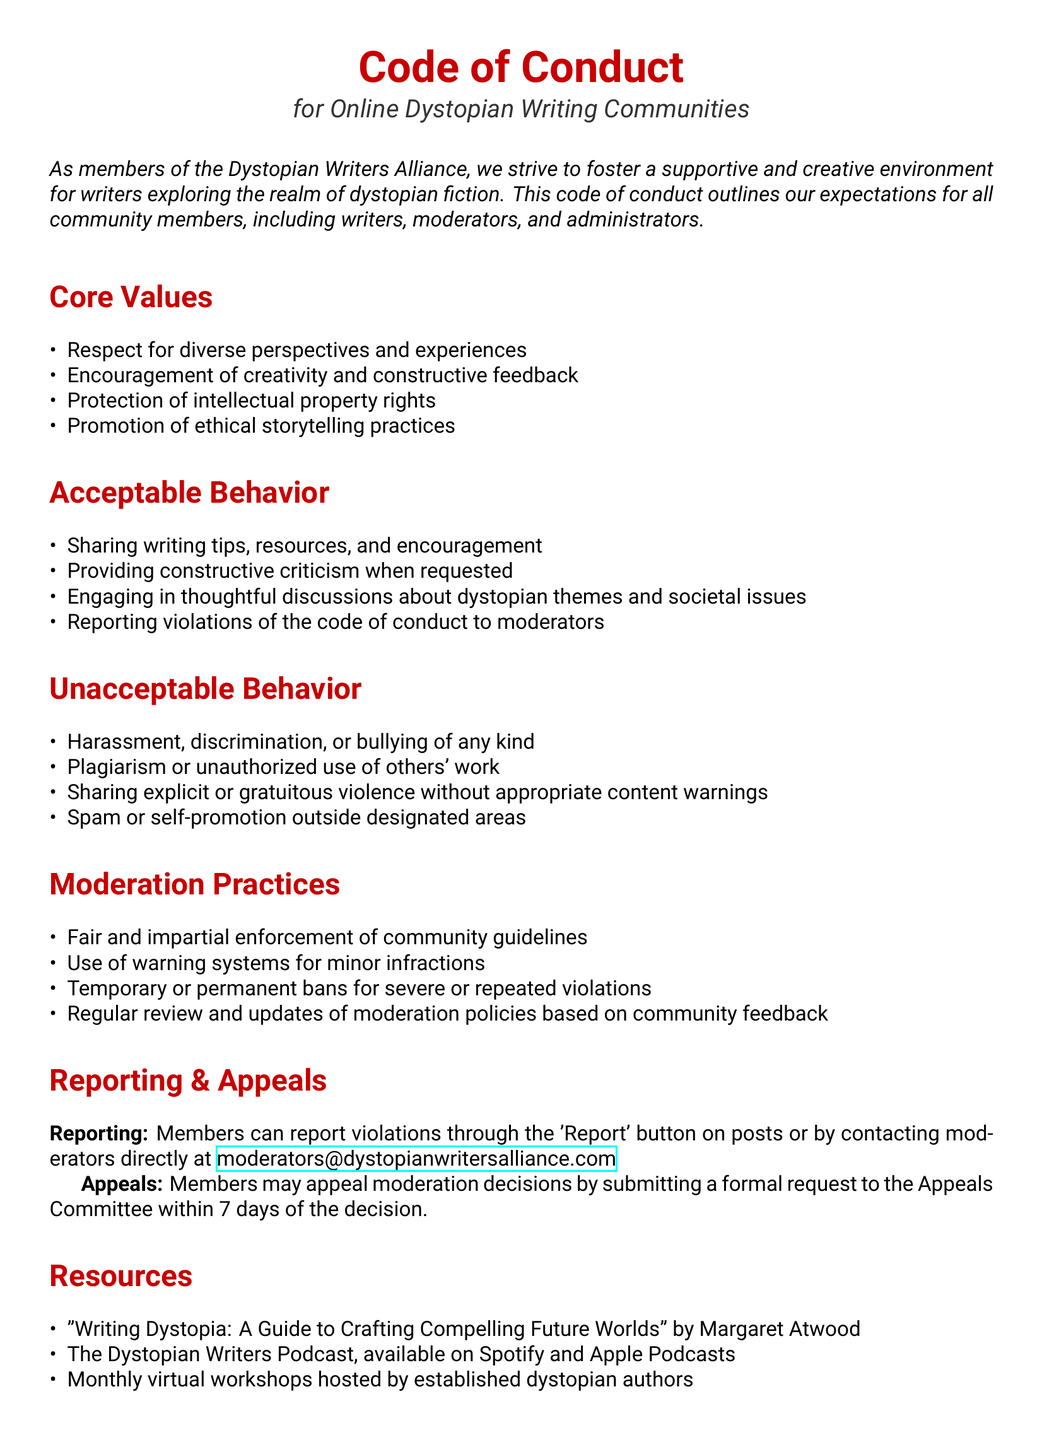What is the title of the document? The title of the document is provided at the top section of the rendered document.
Answer: Code of Conduct Who is the document intended for? The intended audience is specified in the introduction of the document.
Answer: Online Dystopian Writing Communities What is one of the core values mentioned? The document lists core values related to the community's beliefs and practices.
Answer: Respect for diverse perspectives and experiences What behavior is considered acceptable? The document outlines acceptable behavior for community members.
Answer: Sharing writing tips, resources, and encouragement What action can members take if they witness a violation? The document provides guidance on how to address violations of the code of conduct.
Answer: Reporting violations to moderators Which author is referenced in the resources section? The document includes a recommended resource related to writing dystopian fiction.
Answer: Margaret Atwood How long do members have to appeal a moderation decision? The document specifies the timeframe for submitting an appeal after a decision.
Answer: 7 days What type of enforcement is mentioned for community guidelines? The document describes how moderation will be carried out within the community.
Answer: Fair and impartial enforcement What is a consequence for severe or repeated violations? The document outlines consequences for serious infractions of the code of conduct.
Answer: Temporary or permanent bans 